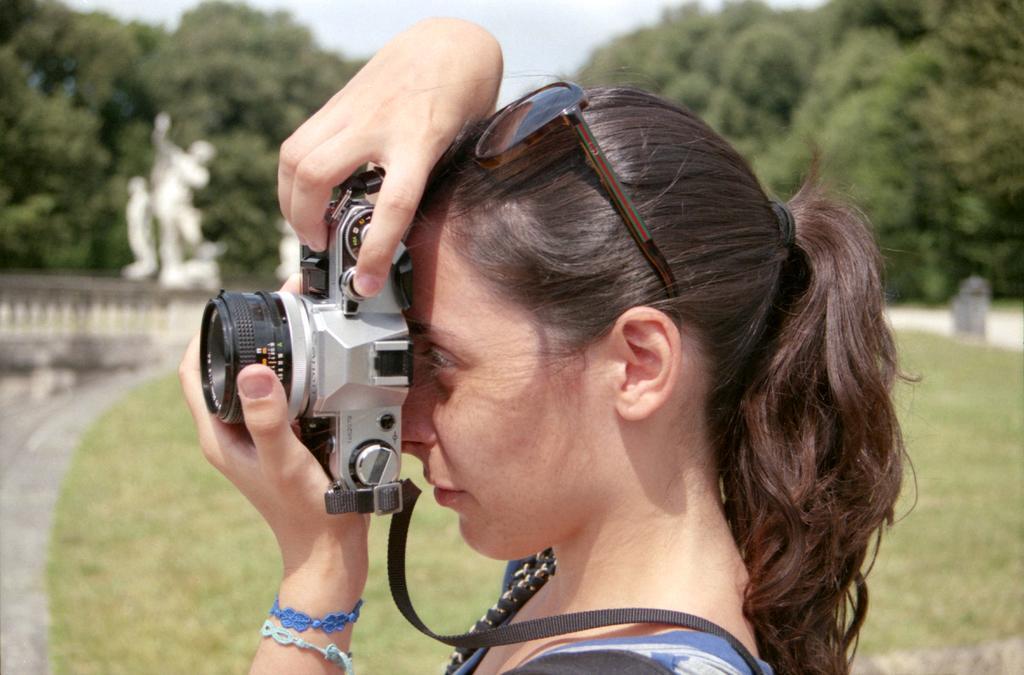Could you give a brief overview of what you see in this image? In the picture we can see a woman standing holding a camera and capturing something, in the background we can see a grass, path, railing, and sculpture which is white in color and some trees with sky. 